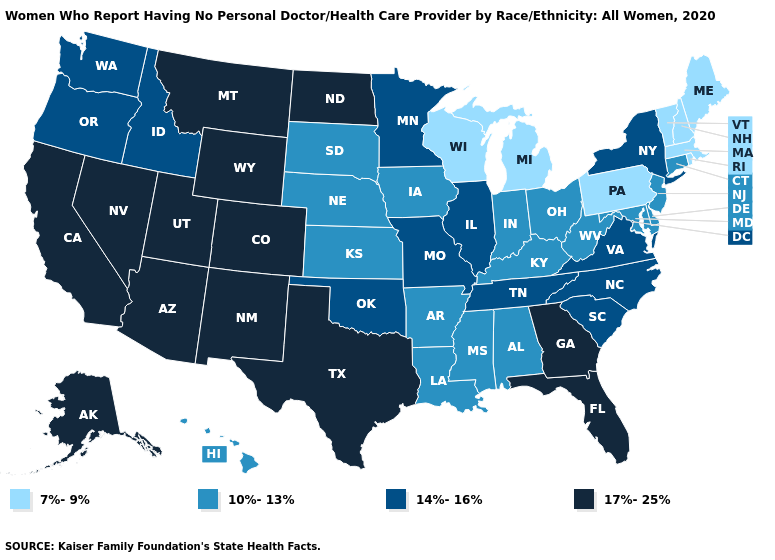Among the states that border Texas , which have the highest value?
Keep it brief. New Mexico. Does Vermont have the lowest value in the Northeast?
Write a very short answer. Yes. Does South Dakota have the highest value in the MidWest?
Write a very short answer. No. Which states hav the highest value in the West?
Answer briefly. Alaska, Arizona, California, Colorado, Montana, Nevada, New Mexico, Utah, Wyoming. What is the value of Nevada?
Write a very short answer. 17%-25%. What is the highest value in states that border Minnesota?
Concise answer only. 17%-25%. Does Georgia have the highest value in the USA?
Short answer required. Yes. What is the highest value in the Northeast ?
Write a very short answer. 14%-16%. Among the states that border Washington , which have the highest value?
Give a very brief answer. Idaho, Oregon. Does the first symbol in the legend represent the smallest category?
Be succinct. Yes. Name the states that have a value in the range 14%-16%?
Quick response, please. Idaho, Illinois, Minnesota, Missouri, New York, North Carolina, Oklahoma, Oregon, South Carolina, Tennessee, Virginia, Washington. Name the states that have a value in the range 7%-9%?
Quick response, please. Maine, Massachusetts, Michigan, New Hampshire, Pennsylvania, Rhode Island, Vermont, Wisconsin. What is the value of Michigan?
Quick response, please. 7%-9%. Does Michigan have the same value as Tennessee?
Answer briefly. No. 